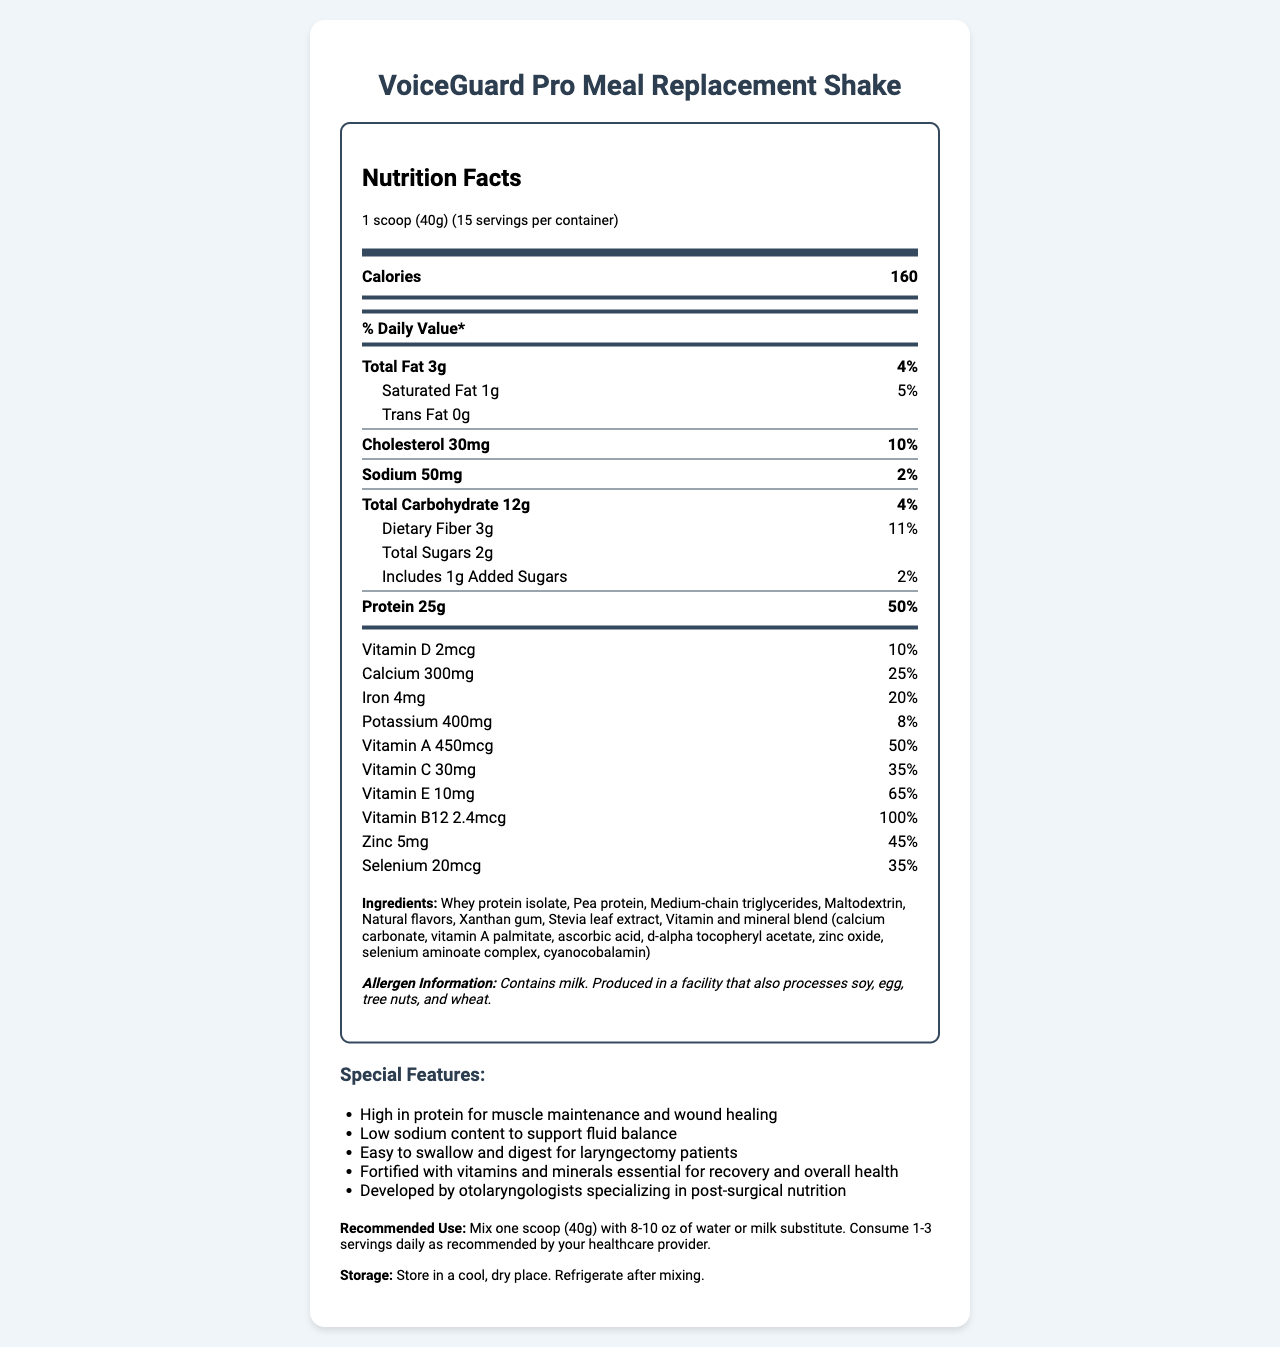what is the serving size? The serving size is clearly listed under the serving information in the document.
Answer: 1 scoop (40g) how many calories are in one serving? The calories per serving are displayed prominently in the main nutrition label.
Answer: 160 what is the total amount of protein per serving? Within the nutrition facts section, the protein content per serving is shown as 25g.
Answer: 25g how much calcium does one serving provide? The amount of calcium per serving is listed in the vitamin and mineral section of the document.
Answer: 300mg what are the primary ingredients? The ingredients are provided under the ingredients section, listing all primary components.
Answer: Whey protein isolate, Pea protein, Medium-chain triglycerides, Maltodextrin, Natural flavors, Xanthan gum, Stevia leaf extract, Vitamin and mineral blend what percentage of the daily value does one serving of saturated fat provide? The percent daily value for saturated fat is listed next to the amount of saturated fat.
Answer: 5% how much dietary fiber is in each serving? The dietary fiber content per serving is specified in the nutrition label.
Answer: 3g what is the cholesterol content per serving? The cholesterol content per serving is provided under the main nutrition facts section.
Answer: 30mg what is the sodium content of each serving? A. 30mg B. 40mg C. 50mg D. 60mg The sodium content per serving is listed as 50mg.
Answer: C. 50mg which vitamin has the highest % daily value per serving? A. Vitamin D B. Vitamin C C. Vitamin B12 D. Zinc Vitamin B12 provides 100% of the daily value per serving, higher than any other vitamin or mineral listed.
Answer: C. Vitamin B12 is the product suitable for individuals allergic to milk? The allergen information states that the product contains milk.
Answer: No is the "VoiceGuard Pro Meal Replacement Shake" high in protein? The shake provides 25g of protein per serving, which is 50% of the daily value.
Answer: Yes summarize the main features and nutritional benefits of "VoiceGuard Pro Meal Replacement Shake." The document outlines the shake's high protein content, low sodium levels, and inclusion of various vitamins and minerals. It also emphasizes the product's development by experts and its suitability for post-surgical patients.
Answer: The "VoiceGuard Pro Meal Replacement Shake" is a high-protein (25g per serving), low-sodium (50mg per serving) meal replacement designed for laryngectomy patients. It contains a diverse blend of vitamins and minerals to support recovery and overall health. The product is easy to swallow, fortified with essential nutrients, and developed by otolaryngologists specializing in post-surgical nutrition. how much vitamin C does the shake provide? Vitamin C content is listed in the vitamins and minerals section of the nutrition label.
Answer: 30mg how many servings are there in a container? The serving information at the top of the document states there are 15 servings per container.
Answer: 15 does the product contain any added sugars? The nutrition facts indicate that the product includes 1g of added sugars per serving.
Answer: Yes is there enough information to determine if this product is vegan? The ingredient list includes whey protein isolate which is derived from milk, but the document does not specify whether all other ingredients are vegan and whether any other non-vegan processing occurs.
Answer: Not enough information what is the primary benefit of the low-sodium content feature? The special features section states that the low sodium content is to support fluid balance, making it beneficial for patients managing their fluid intake.
Answer: To support fluid balance 